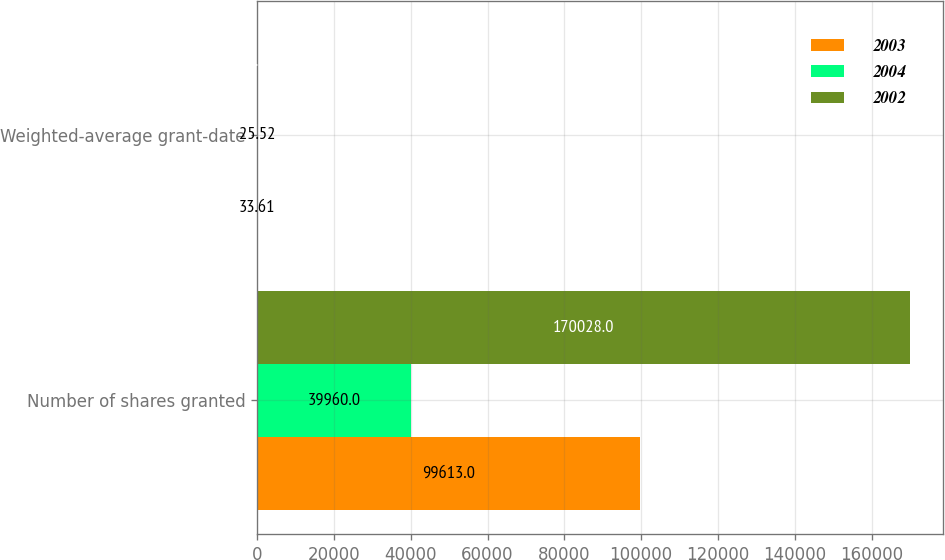Convert chart to OTSL. <chart><loc_0><loc_0><loc_500><loc_500><stacked_bar_chart><ecel><fcel>Number of shares granted<fcel>Weighted-average grant-date<nl><fcel>2003<fcel>99613<fcel>33.61<nl><fcel>2004<fcel>39960<fcel>25.52<nl><fcel>2002<fcel>170028<fcel>27.84<nl></chart> 